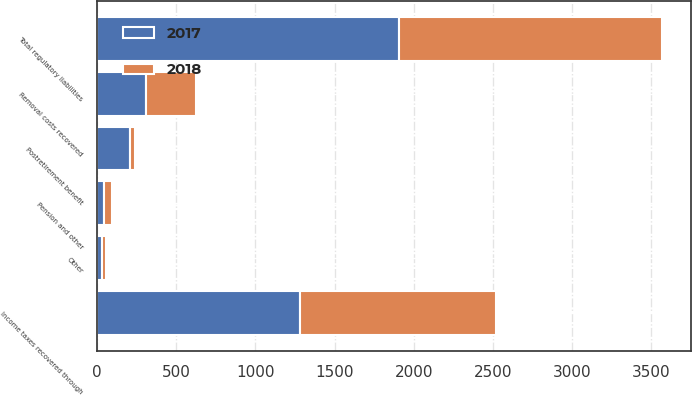Convert chart to OTSL. <chart><loc_0><loc_0><loc_500><loc_500><stacked_bar_chart><ecel><fcel>Income taxes recovered through<fcel>Removal costs recovered<fcel>Postretirement benefit<fcel>Pension and other<fcel>Other<fcel>Total regulatory liabilities<nl><fcel>2017<fcel>1279<fcel>309<fcel>209<fcel>46<fcel>28<fcel>1907<nl><fcel>2018<fcel>1242<fcel>315<fcel>33<fcel>48<fcel>26<fcel>1664<nl></chart> 